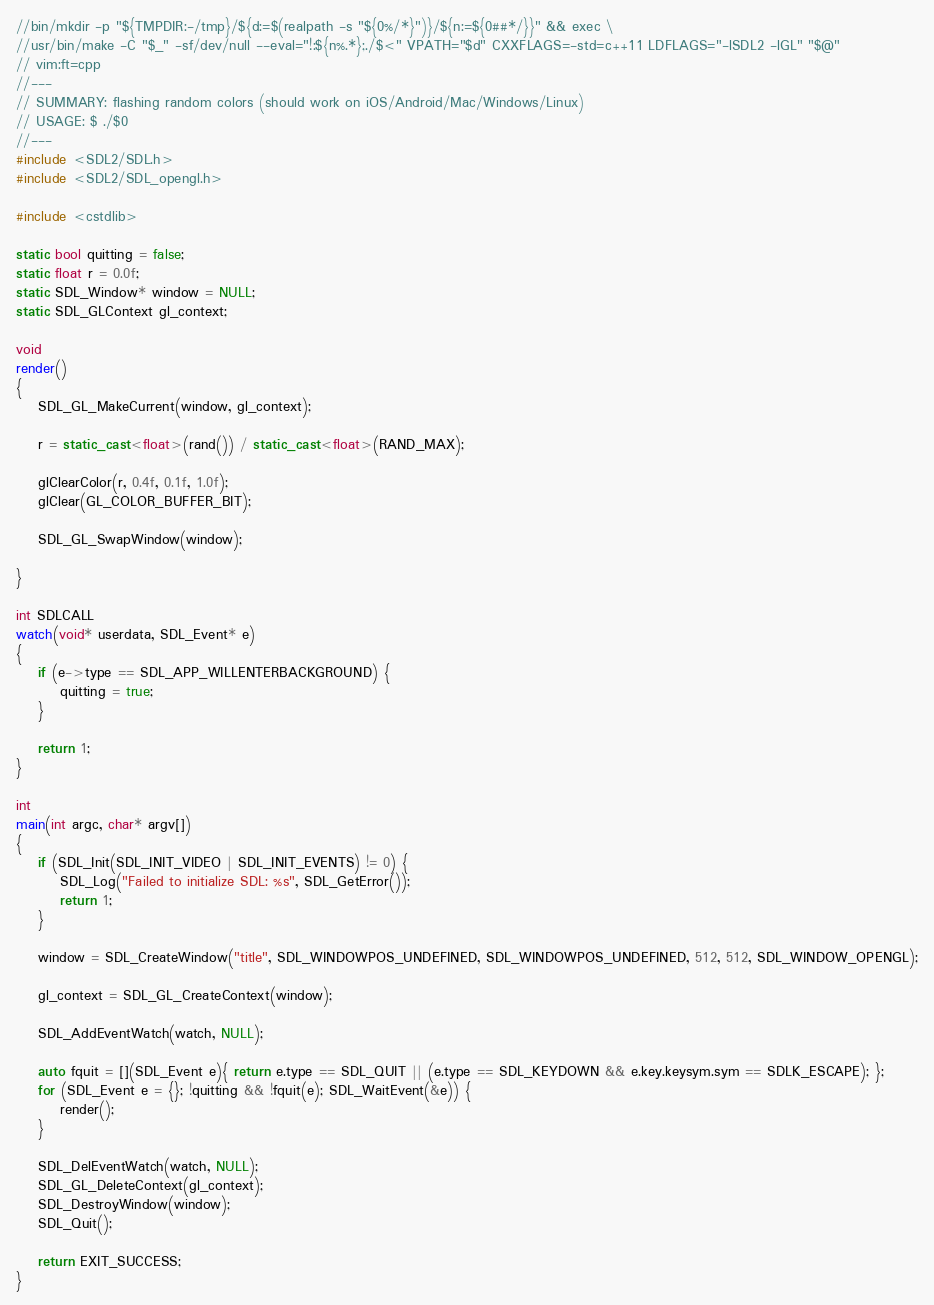Convert code to text. <code><loc_0><loc_0><loc_500><loc_500><_C++_>//bin/mkdir -p "${TMPDIR:-/tmp}/${d:=$(realpath -s "${0%/*}")}/${n:=${0##*/}}" && exec \
//usr/bin/make -C "$_" -sf/dev/null --eval="!:${n%.*};./$<" VPATH="$d" CXXFLAGS=-std=c++11 LDFLAGS="-lSDL2 -lGL" "$@"
// vim:ft=cpp
//---
// SUMMARY: flashing random colors (should work on iOS/Android/Mac/Windows/Linux)
// USAGE: $ ./$0
//---
#include <SDL2/SDL.h>
#include <SDL2/SDL_opengl.h>

#include <cstdlib>

static bool quitting = false;
static float r = 0.0f;
static SDL_Window* window = NULL;
static SDL_GLContext gl_context;

void
render()
{
    SDL_GL_MakeCurrent(window, gl_context);

    r = static_cast<float>(rand()) / static_cast<float>(RAND_MAX);

    glClearColor(r, 0.4f, 0.1f, 1.0f);
    glClear(GL_COLOR_BUFFER_BIT);

    SDL_GL_SwapWindow(window);

}

int SDLCALL
watch(void* userdata, SDL_Event* e)
{
    if (e->type == SDL_APP_WILLENTERBACKGROUND) {
        quitting = true;
    }

    return 1;
}

int
main(int argc, char* argv[])
{
    if (SDL_Init(SDL_INIT_VIDEO | SDL_INIT_EVENTS) != 0) {
        SDL_Log("Failed to initialize SDL: %s", SDL_GetError());
        return 1;
    }

    window = SDL_CreateWindow("title", SDL_WINDOWPOS_UNDEFINED, SDL_WINDOWPOS_UNDEFINED, 512, 512, SDL_WINDOW_OPENGL);

    gl_context = SDL_GL_CreateContext(window);

    SDL_AddEventWatch(watch, NULL);

    auto fquit = [](SDL_Event e){ return e.type == SDL_QUIT || (e.type == SDL_KEYDOWN && e.key.keysym.sym == SDLK_ESCAPE); };
    for (SDL_Event e = {}; !quitting && !fquit(e); SDL_WaitEvent(&e)) {
        render();
    }

    SDL_DelEventWatch(watch, NULL);
    SDL_GL_DeleteContext(gl_context);
    SDL_DestroyWindow(window);
    SDL_Quit();

    return EXIT_SUCCESS;
}
</code> 